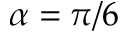Convert formula to latex. <formula><loc_0><loc_0><loc_500><loc_500>\alpha = \pi / 6</formula> 